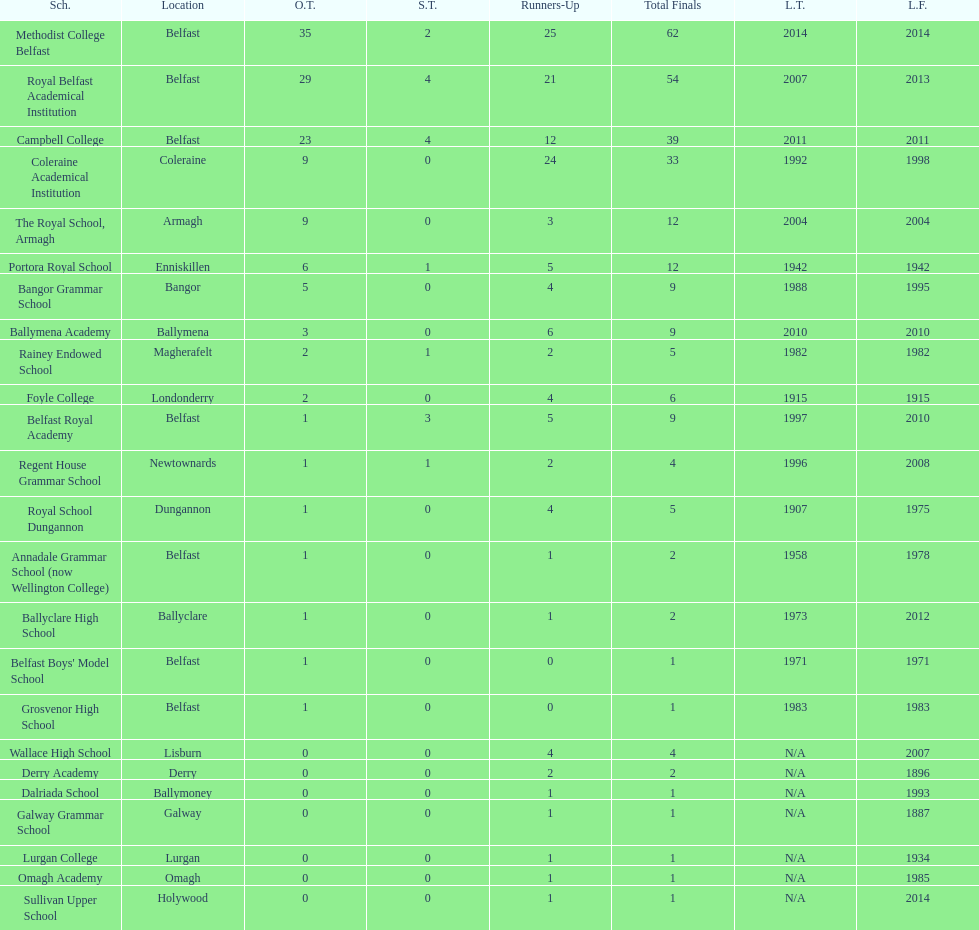Did belfast royal academy have more or less total finals than ballyclare high school? More. 